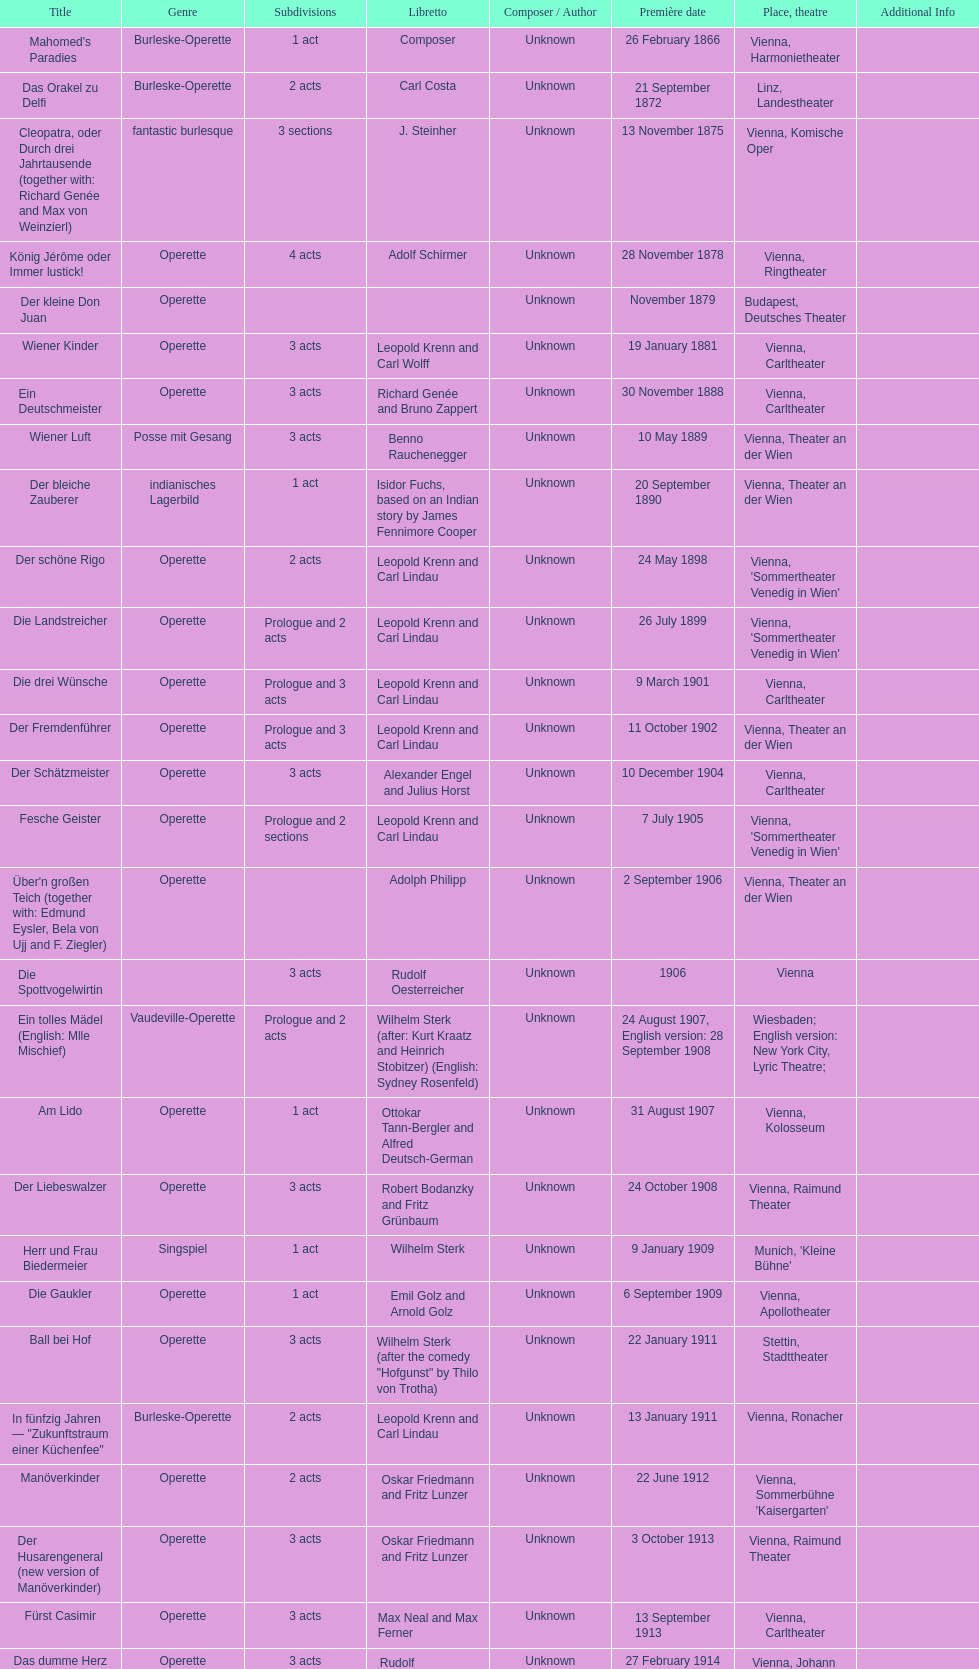What are the number of titles that premiered in the month of september? 4. 